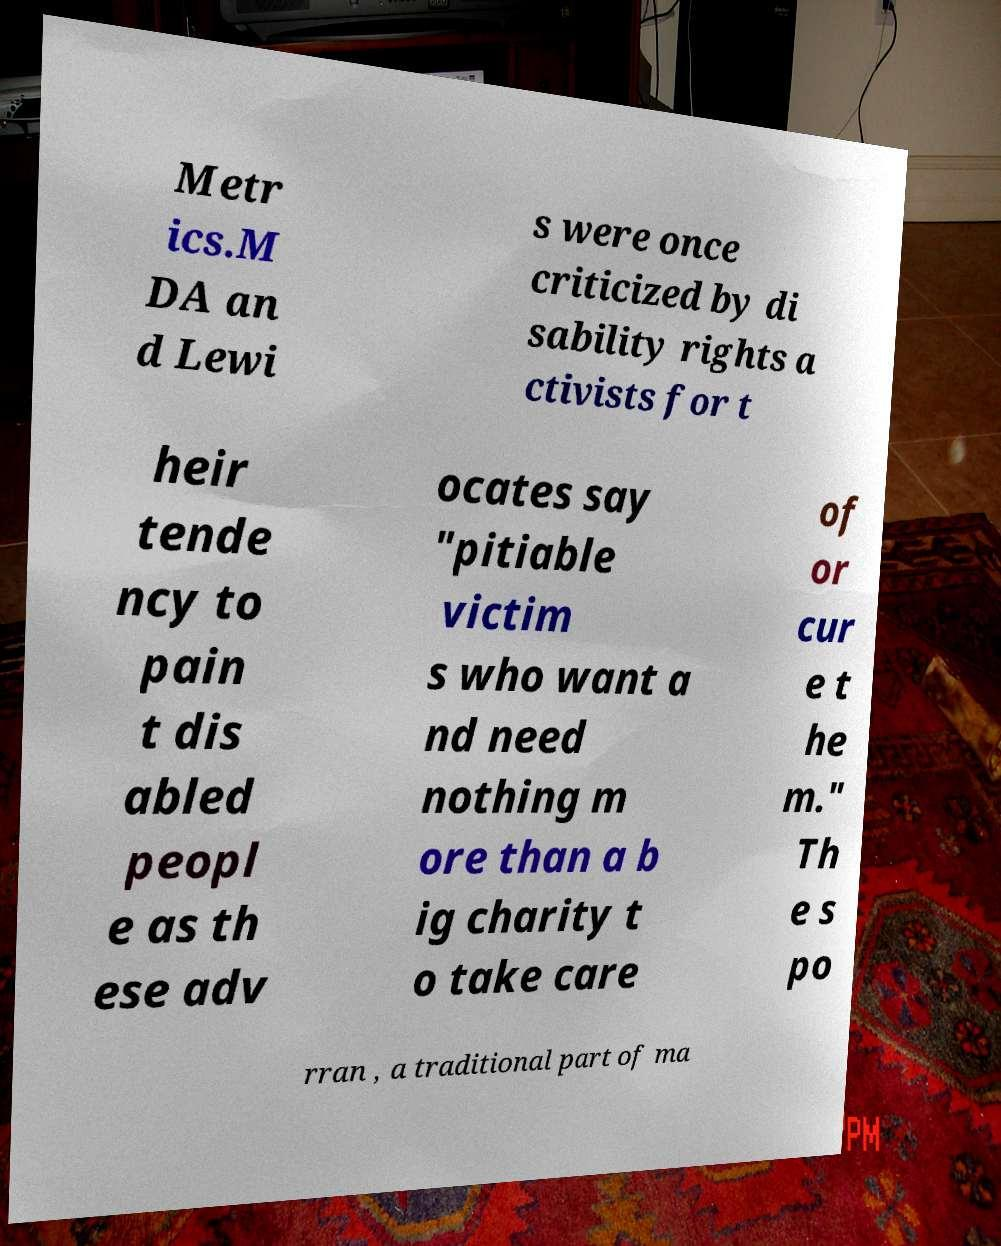There's text embedded in this image that I need extracted. Can you transcribe it verbatim? Metr ics.M DA an d Lewi s were once criticized by di sability rights a ctivists for t heir tende ncy to pain t dis abled peopl e as th ese adv ocates say "pitiable victim s who want a nd need nothing m ore than a b ig charity t o take care of or cur e t he m." Th e s po rran , a traditional part of ma 